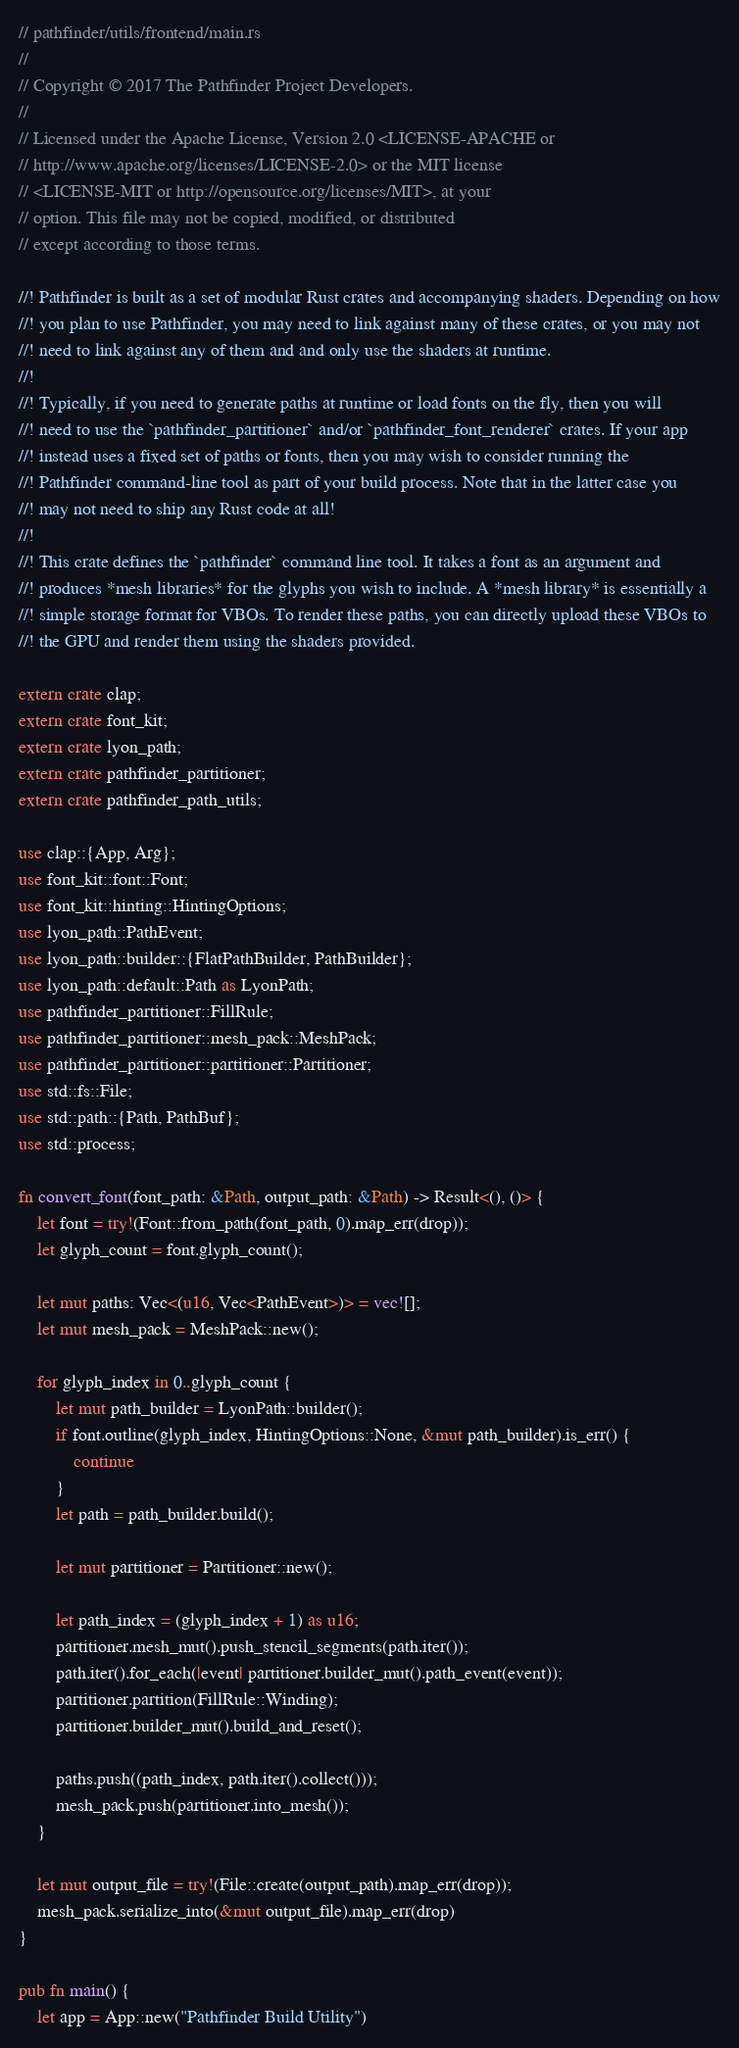Convert code to text. <code><loc_0><loc_0><loc_500><loc_500><_Rust_>// pathfinder/utils/frontend/main.rs
//
// Copyright © 2017 The Pathfinder Project Developers.
//
// Licensed under the Apache License, Version 2.0 <LICENSE-APACHE or
// http://www.apache.org/licenses/LICENSE-2.0> or the MIT license
// <LICENSE-MIT or http://opensource.org/licenses/MIT>, at your
// option. This file may not be copied, modified, or distributed
// except according to those terms.

//! Pathfinder is built as a set of modular Rust crates and accompanying shaders. Depending on how
//! you plan to use Pathfinder, you may need to link against many of these crates, or you may not
//! need to link against any of them and and only use the shaders at runtime.
//!
//! Typically, if you need to generate paths at runtime or load fonts on the fly, then you will
//! need to use the `pathfinder_partitioner` and/or `pathfinder_font_renderer` crates. If your app
//! instead uses a fixed set of paths or fonts, then you may wish to consider running the
//! Pathfinder command-line tool as part of your build process. Note that in the latter case you
//! may not need to ship any Rust code at all!
//!
//! This crate defines the `pathfinder` command line tool. It takes a font as an argument and
//! produces *mesh libraries* for the glyphs you wish to include. A *mesh library* is essentially a
//! simple storage format for VBOs. To render these paths, you can directly upload these VBOs to
//! the GPU and render them using the shaders provided.

extern crate clap;
extern crate font_kit;
extern crate lyon_path;
extern crate pathfinder_partitioner;
extern crate pathfinder_path_utils;

use clap::{App, Arg};
use font_kit::font::Font;
use font_kit::hinting::HintingOptions;
use lyon_path::PathEvent;
use lyon_path::builder::{FlatPathBuilder, PathBuilder};
use lyon_path::default::Path as LyonPath;
use pathfinder_partitioner::FillRule;
use pathfinder_partitioner::mesh_pack::MeshPack;
use pathfinder_partitioner::partitioner::Partitioner;
use std::fs::File;
use std::path::{Path, PathBuf};
use std::process;

fn convert_font(font_path: &Path, output_path: &Path) -> Result<(), ()> {
    let font = try!(Font::from_path(font_path, 0).map_err(drop));
    let glyph_count = font.glyph_count();

    let mut paths: Vec<(u16, Vec<PathEvent>)> = vec![];
    let mut mesh_pack = MeshPack::new();

    for glyph_index in 0..glyph_count {
        let mut path_builder = LyonPath::builder();
        if font.outline(glyph_index, HintingOptions::None, &mut path_builder).is_err() {
            continue
        }
        let path = path_builder.build();

        let mut partitioner = Partitioner::new();

        let path_index = (glyph_index + 1) as u16;
        partitioner.mesh_mut().push_stencil_segments(path.iter());
        path.iter().for_each(|event| partitioner.builder_mut().path_event(event));
        partitioner.partition(FillRule::Winding);
        partitioner.builder_mut().build_and_reset();

        paths.push((path_index, path.iter().collect()));
        mesh_pack.push(partitioner.into_mesh());
    }

    let mut output_file = try!(File::create(output_path).map_err(drop));
    mesh_pack.serialize_into(&mut output_file).map_err(drop)
}

pub fn main() {
    let app = App::new("Pathfinder Build Utility")</code> 